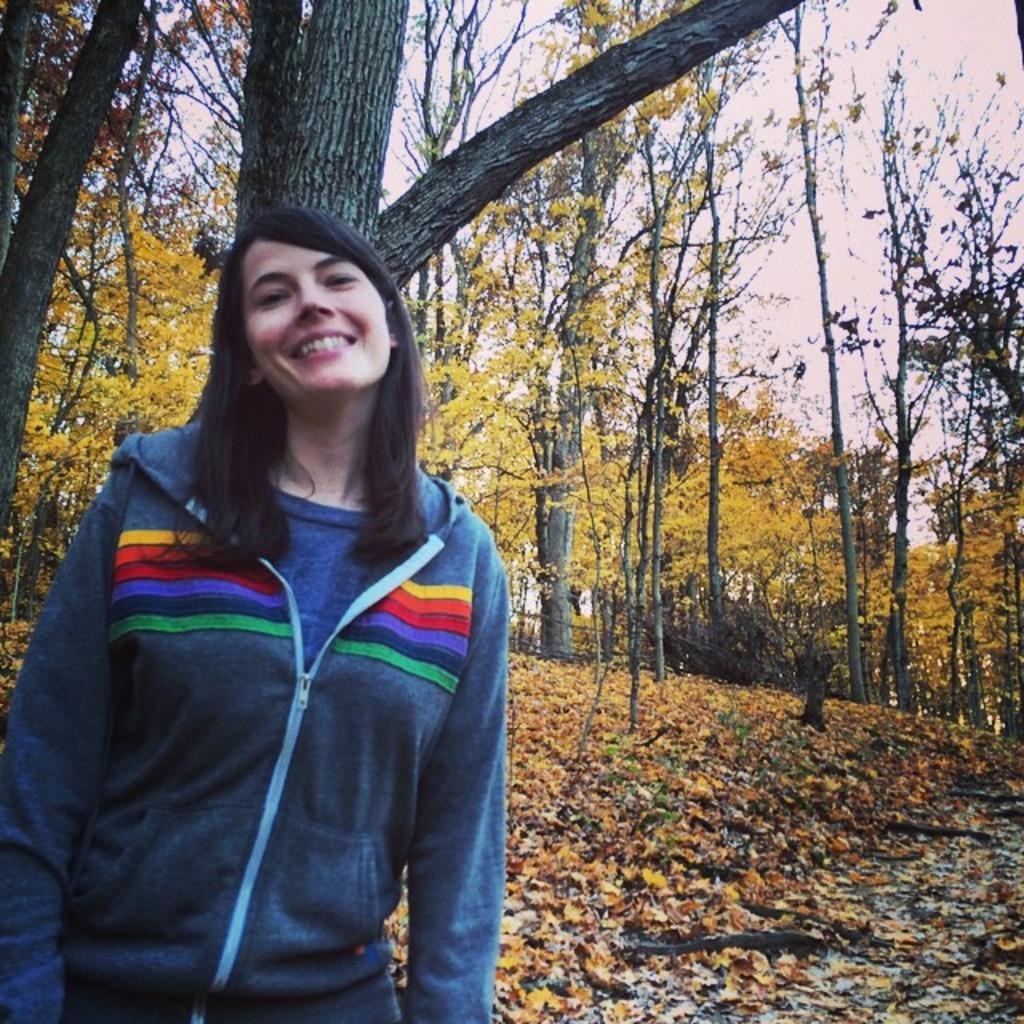How would you summarize this image in a sentence or two? In this image we can see there is a person standing and at the back we can see the trees. And at the bottom we can see the leaves and the sky in the background. 